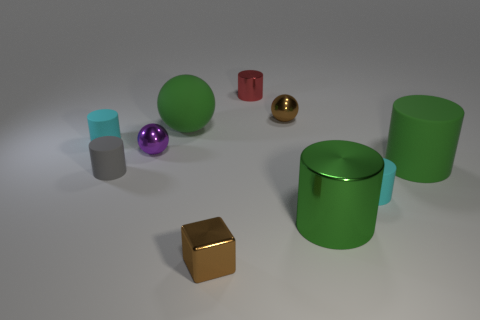What is the material of the cylinder on the right side of the tiny cyan rubber cylinder right of the small brown object behind the tiny gray thing?
Provide a short and direct response. Rubber. Are there any gray matte things?
Ensure brevity in your answer.  Yes. Do the big rubber ball and the small sphere on the left side of the brown ball have the same color?
Offer a terse response. No. The small cube is what color?
Your answer should be compact. Brown. Is there any other thing that has the same shape as the tiny red shiny thing?
Offer a very short reply. Yes. The other big rubber object that is the same shape as the gray rubber thing is what color?
Provide a succinct answer. Green. Does the red thing have the same shape as the gray thing?
Offer a very short reply. Yes. How many blocks are small green matte things or big green metal things?
Keep it short and to the point. 0. What color is the large object that is the same material as the cube?
Offer a terse response. Green. There is a cyan matte cylinder that is on the left side of the red thing; does it have the same size as the small purple metal object?
Offer a very short reply. Yes. 